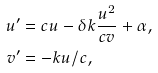Convert formula to latex. <formula><loc_0><loc_0><loc_500><loc_500>u ^ { \prime } & = c u - \delta k \frac { u ^ { 2 } } { c v } + \alpha , \\ v ^ { \prime } & = - k u / c ,</formula> 